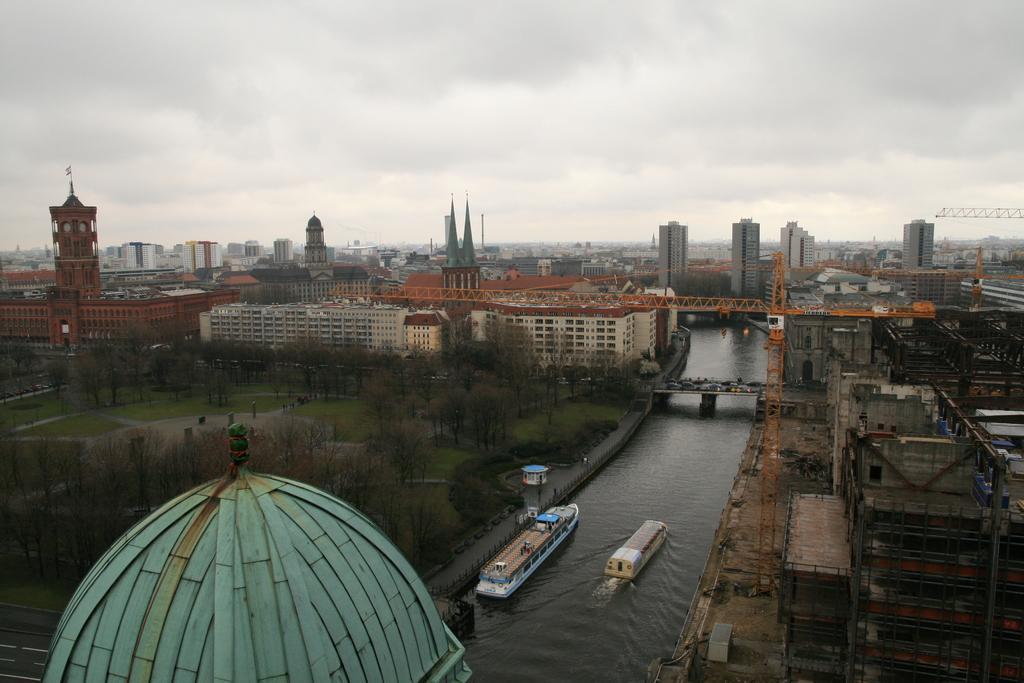Could you give a brief overview of what you see in this image? In this image I can see few buildings, few cranes, few other buildings which are under construction, the water, few boats on the surface of the water, a bridge, few vehicles on the bridge, few trees and some grass on the ground. In the background I can see few buildings and the sky. 